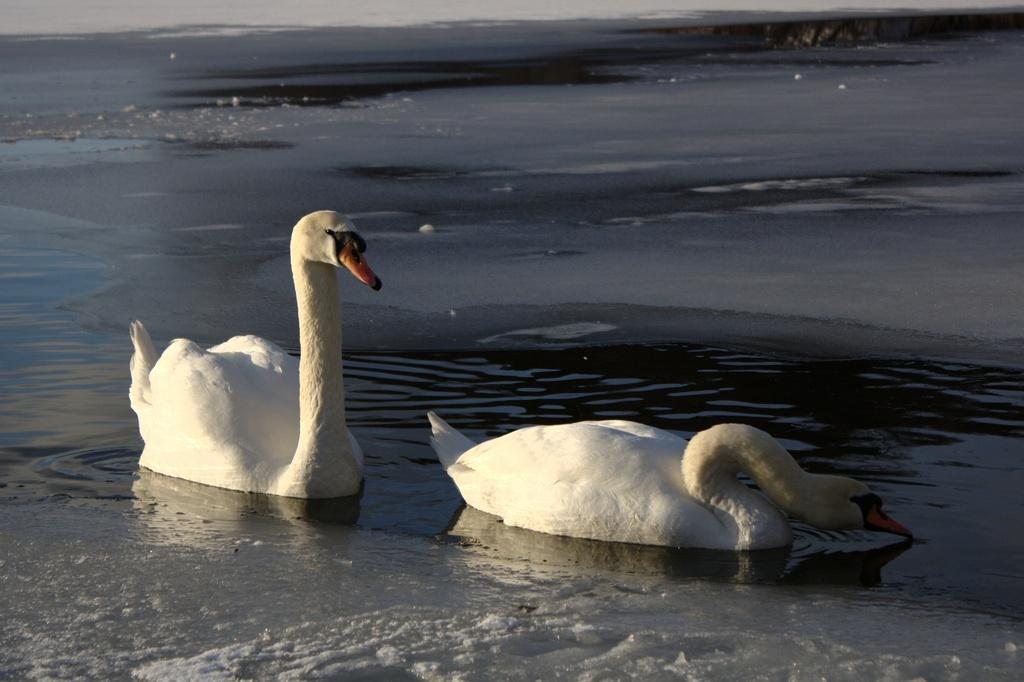What is the primary element in the image? The image consists of water. What animals can be seen in the water? There are swans in the water. What color are the swans? The swans are white in color. Who is the manager of the swans in the image? There is no indication of a manager for the swans in the image. How many fingers can be seen in the image? There are no fingers visible in the image, as it only features water and swans. 